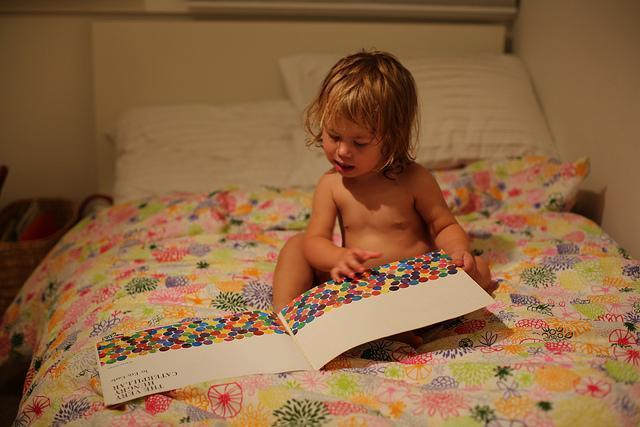How many pillows are there?
Give a very brief answer. 2. How many people are there?
Give a very brief answer. 1. How many people reaching for the frisbee are wearing red?
Give a very brief answer. 0. 